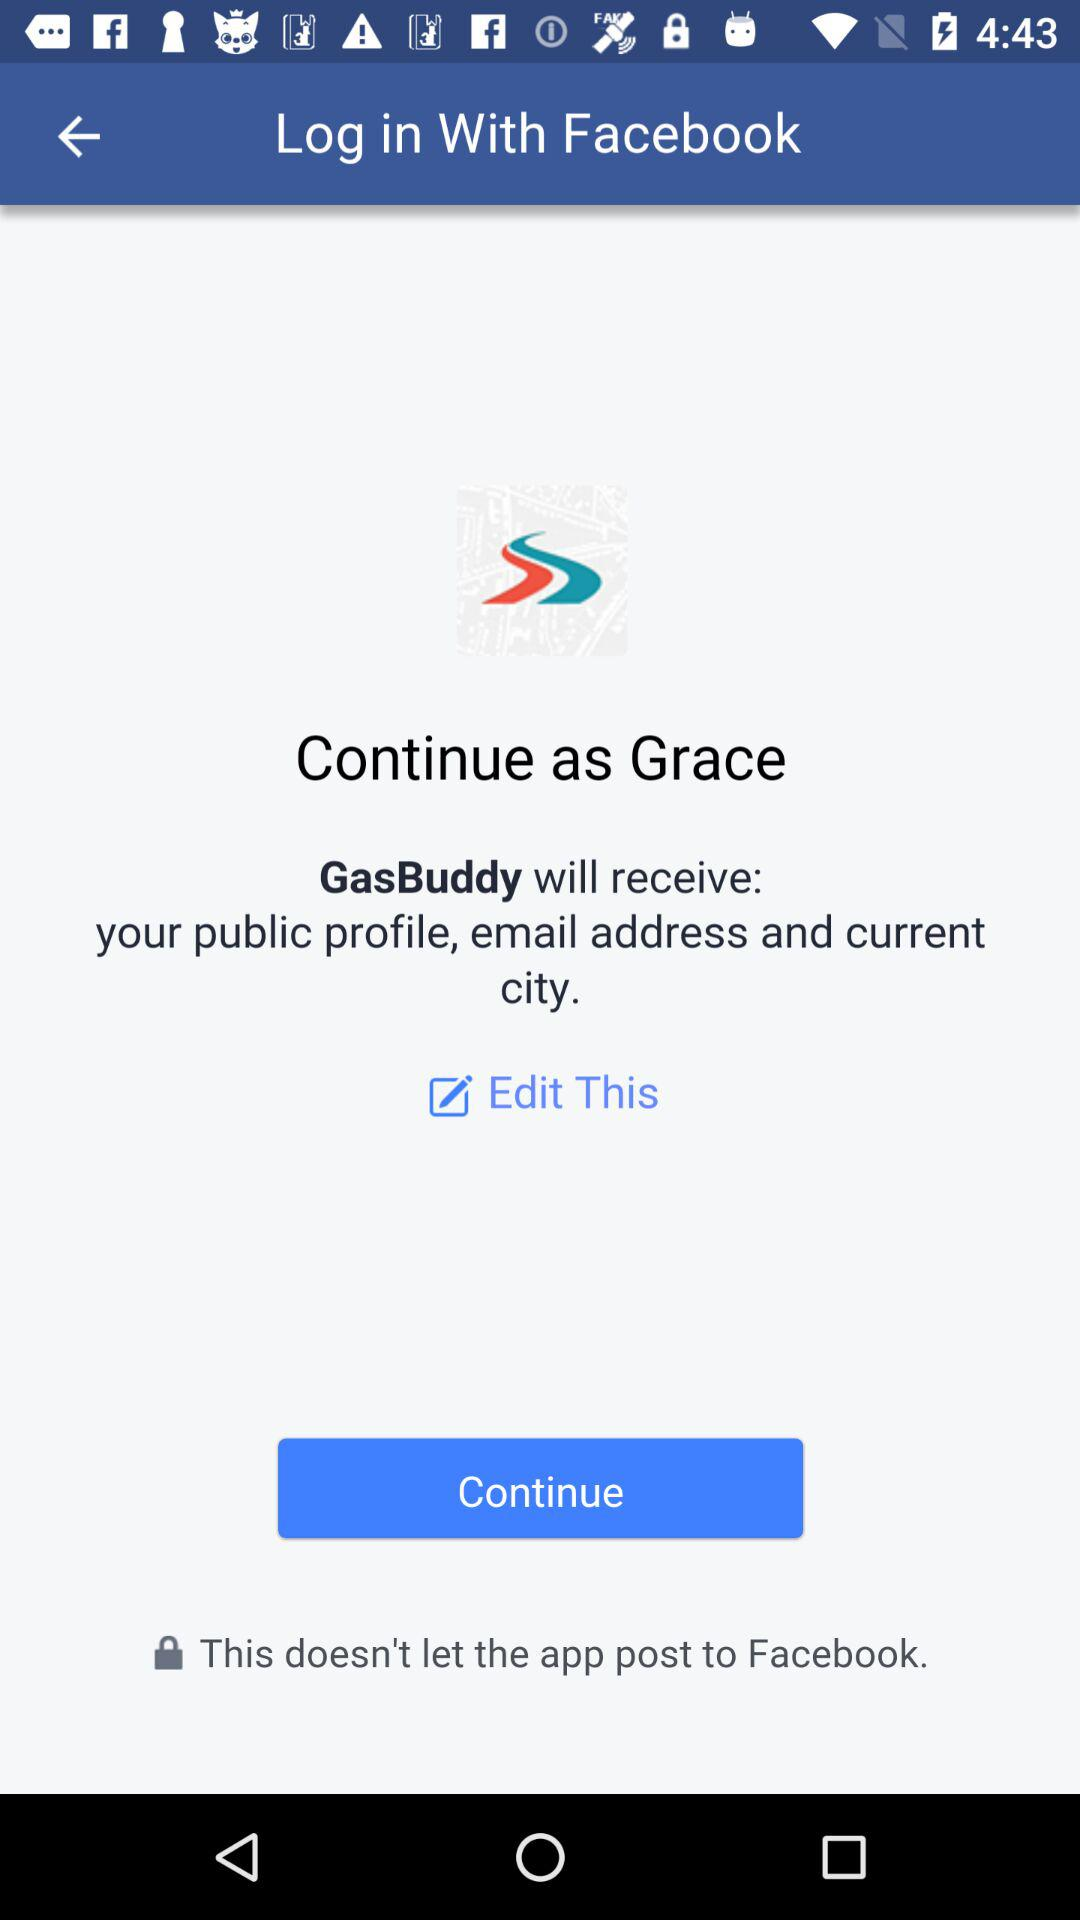What is the name of the user? The name of the user is Grace. 